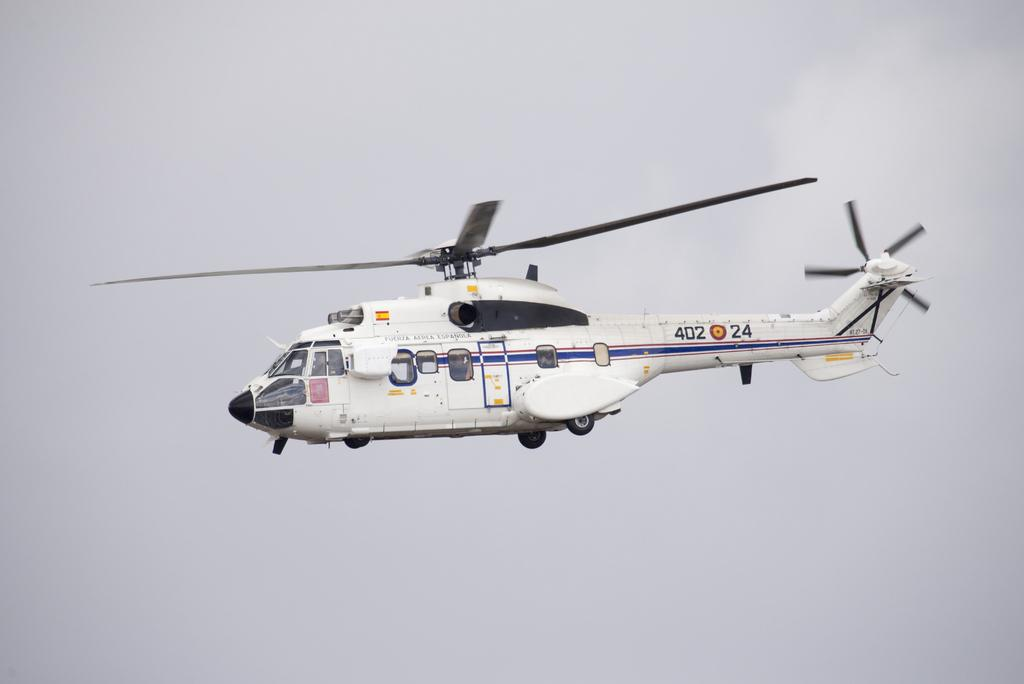What is the main subject of the image? The main subject of the image is a helicopter. What color is the helicopter? The helicopter is white in color. What is the helicopter doing in the image? The helicopter is flying in the sky. Where is the locket hanging from the helicopter in the image? There is no locket present in the image; it only features a white helicopter flying in the sky. 